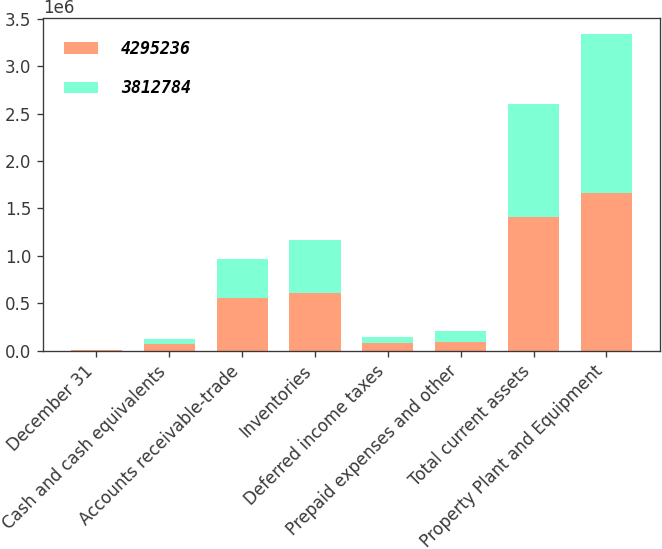Convert chart. <chart><loc_0><loc_0><loc_500><loc_500><stacked_bar_chart><ecel><fcel>December 31<fcel>Cash and cash equivalents<fcel>Accounts receivable-trade<fcel>Inventories<fcel>Deferred income taxes<fcel>Prepaid expenses and other<fcel>Total current assets<fcel>Property Plant and Equipment<nl><fcel>4.29524e+06<fcel>2005<fcel>67183<fcel>559289<fcel>610284<fcel>78196<fcel>93988<fcel>1.40894e+06<fcel>1.65914e+06<nl><fcel>3.81278e+06<fcel>2004<fcel>54837<fcel>408930<fcel>557180<fcel>61756<fcel>114991<fcel>1.19769e+06<fcel>1.6827e+06<nl></chart> 